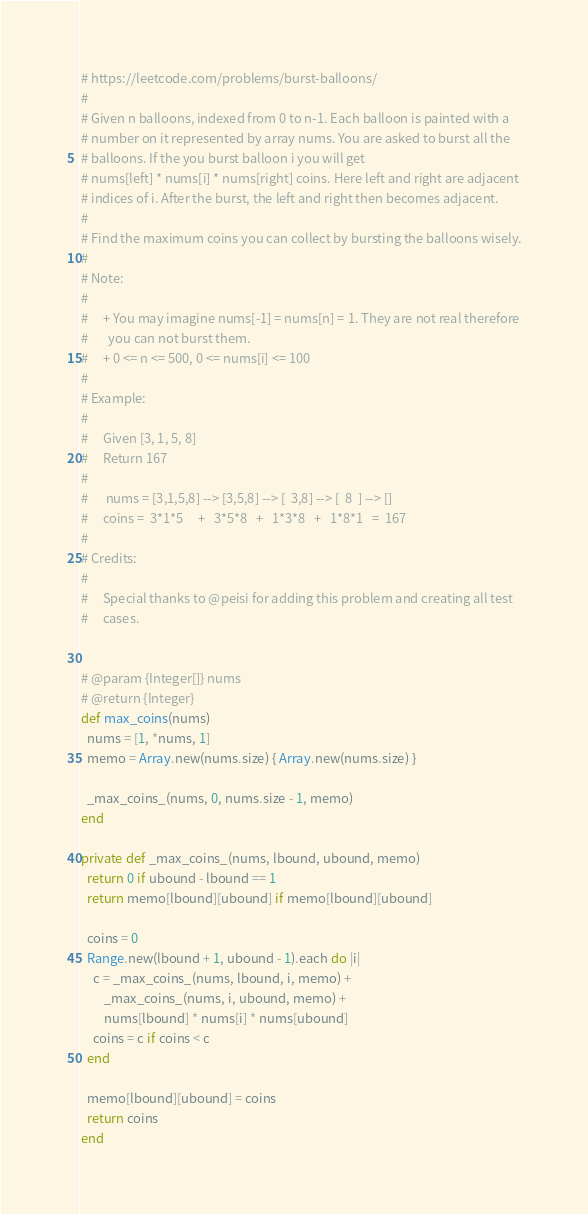Convert code to text. <code><loc_0><loc_0><loc_500><loc_500><_Ruby_># https://leetcode.com/problems/burst-balloons/
#
# Given n balloons, indexed from 0 to n-1. Each balloon is painted with a
# number on it represented by array nums. You are asked to burst all the
# balloons. If the you burst balloon i you will get
# nums[left] * nums[i] * nums[right] coins. Here left and right are adjacent
# indices of i. After the burst, the left and right then becomes adjacent.
#
# Find the maximum coins you can collect by bursting the balloons wisely.
#
# Note:
#
#     + You may imagine nums[-1] = nums[n] = 1. They are not real therefore
#       you can not burst them.
#     + 0 <= n <= 500, 0 <= nums[i] <= 100
#
# Example:
#
#     Given [3, 1, 5, 8]
#     Return 167
#
#      nums = [3,1,5,8] --> [3,5,8] --> [  3,8] --> [  8  ] --> []
#     coins =  3*1*5     +   3*5*8   +   1*3*8   +   1*8*1   =  167
#
# Credits:
#
#     Special thanks to @peisi for adding this problem and creating all test
#     cases.


# @param {Integer[]} nums
# @return {Integer}
def max_coins(nums)
  nums = [1, *nums, 1]
  memo = Array.new(nums.size) { Array.new(nums.size) }

  _max_coins_(nums, 0, nums.size - 1, memo)
end

private def _max_coins_(nums, lbound, ubound, memo)
  return 0 if ubound - lbound == 1
  return memo[lbound][ubound] if memo[lbound][ubound]

  coins = 0
  Range.new(lbound + 1, ubound - 1).each do |i|
    c = _max_coins_(nums, lbound, i, memo) +
        _max_coins_(nums, i, ubound, memo) +
        nums[lbound] * nums[i] * nums[ubound]
    coins = c if coins < c
  end

  memo[lbound][ubound] = coins
  return coins
end
</code> 